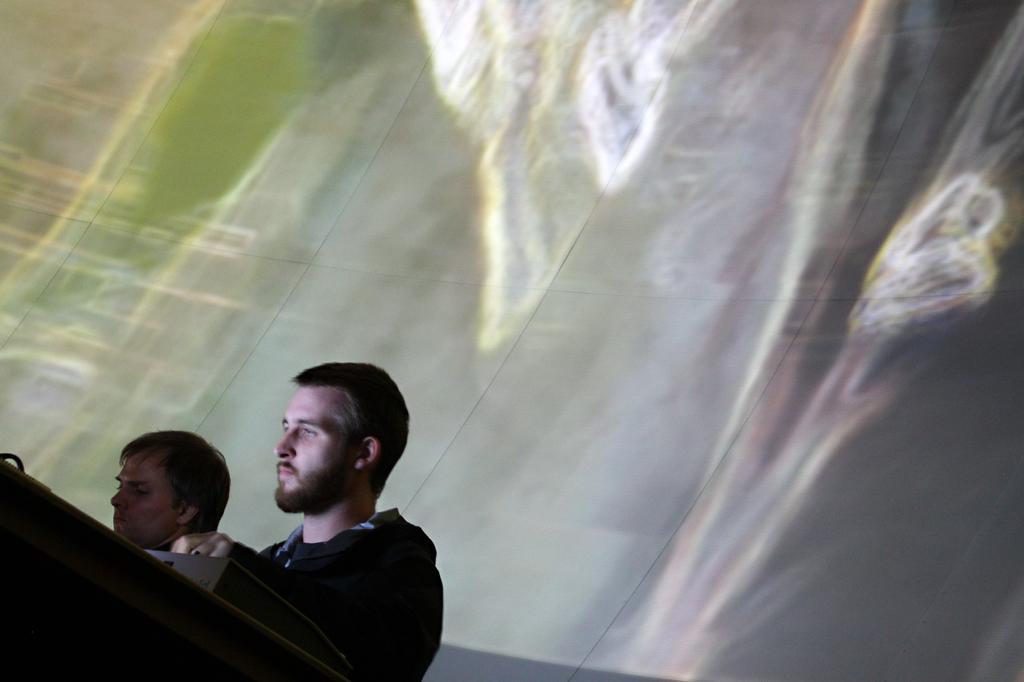Please provide a concise description of this image. In the image I can see two people and some other objects. In the background I can see a wall. 